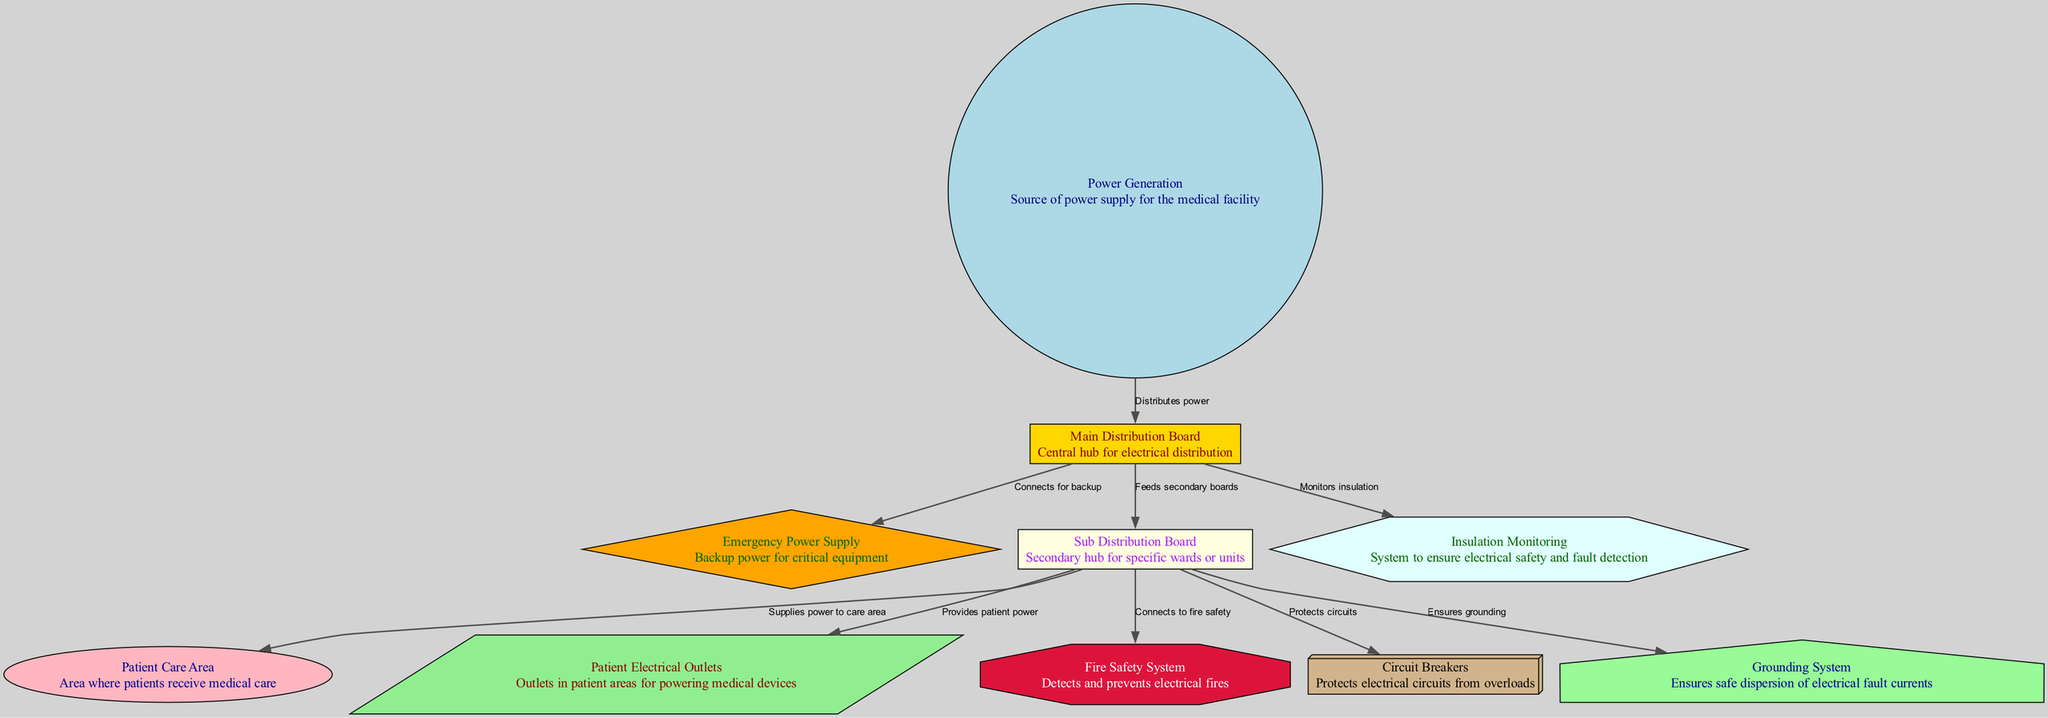What is the main role of the main distribution board? The main distribution board serves as the central hub for electrical distribution in the medical facility, managing power flow from the power generation source. This is indicated in the diagram by the label and description associated with the "main distribution board".
Answer: Central hub for electrical distribution How many nodes are present in the diagram? By counting the individual nodes defined in the provided data, there are ten distinct nodes. Each node is a key component of the electrical wiring and insulation standards in medical environments.
Answer: Ten What connects the main distribution board to the emergency power supply? The connection between the main distribution board and the emergency power supply is labeled as "Connects for backup", which indicates that it is a direct link for providing backup power when needed.
Answer: Connects for backup What is the function of insulation monitoring? Insulation monitoring is a system designed to ensure electrical safety and fault detection. It is monitored from the main distribution board, providing an additional layer of safety for electrical installations. This is clear from the connection labeled as "Monitors insulation".
Answer: Ensures electrical safety and fault detection Which system is responsible for grounding in the diagram? The grounding system is specifically identified as the component that ensures the safe dispersion of electrical fault currents, and is represented as connecting to the sub distribution board.
Answer: Grounding system What is supplied by the sub distribution board to the patient care area? The sub distribution board supplies power to the patient care area, as indicated by the labeled edge connecting these two components. This power supply is critical for the medical care provided in those areas.
Answer: Supplies power to care area How does the fire safety system connect in relation to the sub distribution board? The fire safety system connects directly to the sub distribution board, as shown by the labeled edge "Connects to fire safety". This ensures that electrical circuits can be monitored effectively for fire hazards.
Answer: Connects to fire safety What does the circuit breakers node protect against? The circuit breakers are designed to protect electrical circuits from overloads, as explicitly indicated in the description linked to this node in the diagram.
Answer: Protects electrical circuits from overloads What is the role of electrical outlets in patient care areas? The patient electrical outlets provide necessary power for medical devices used in patient care areas, ensuring that patients receive the required medical attention and equipment operation.
Answer: Provides patient power 